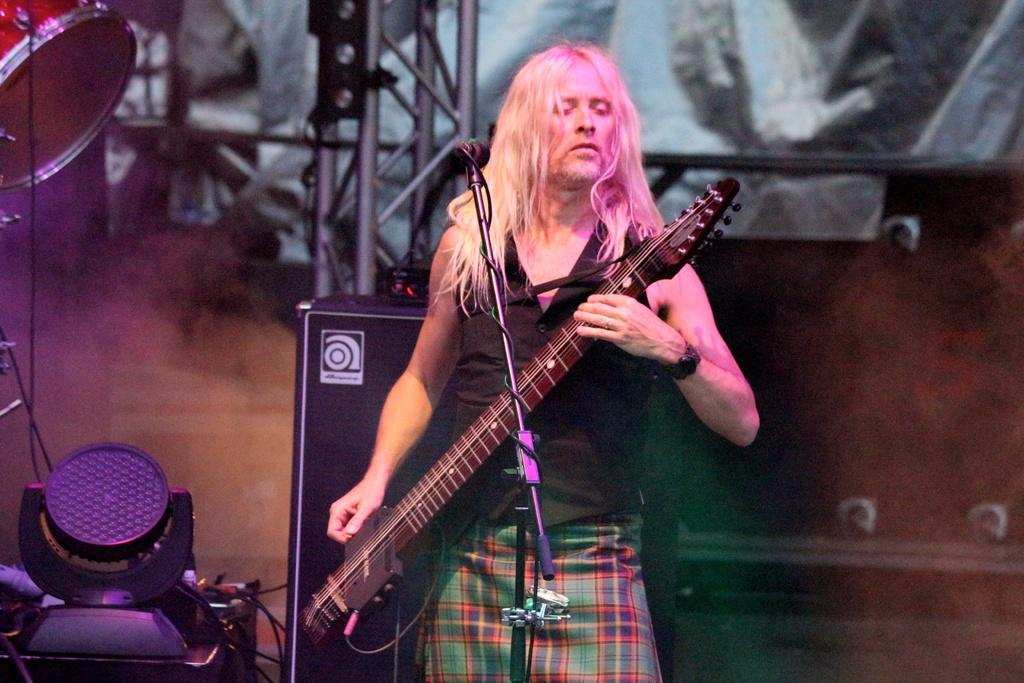What is the main subject of the image? There is a person in the image. What is the person doing in the image? The person is standing and playing a musical instrument. What type of stone is the ghost holding in the image? There is no ghost or stone present in the image; it features a person playing a musical instrument. 